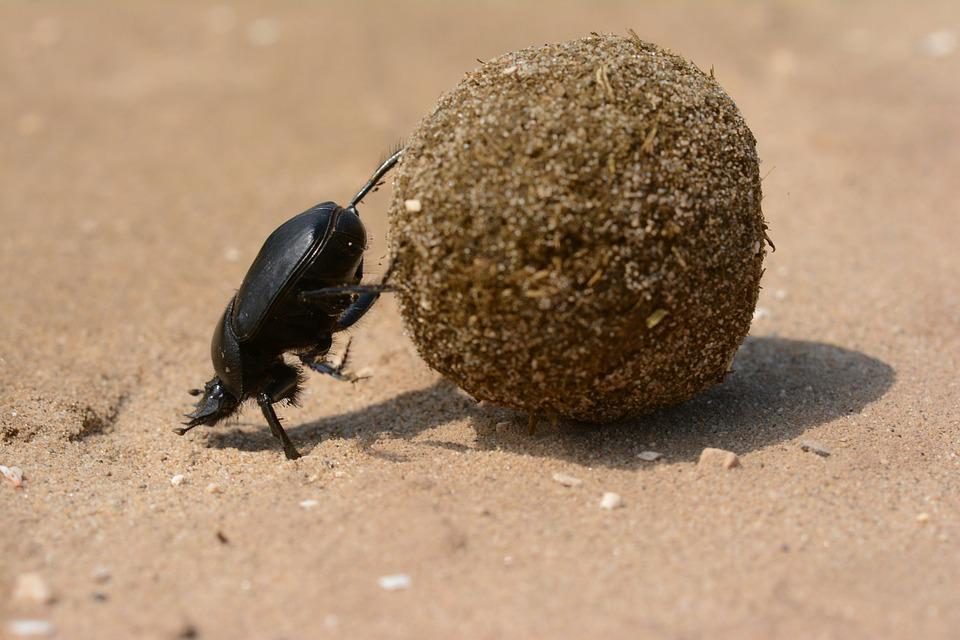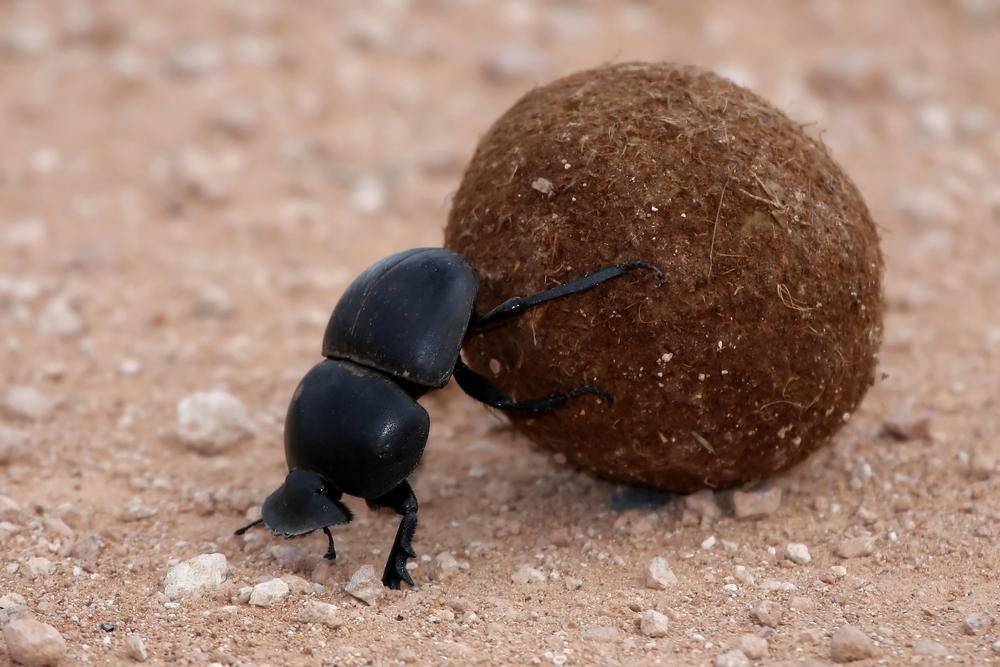The first image is the image on the left, the second image is the image on the right. For the images shown, is this caption "A beetle is turned toward the left side of the photo in both images." true? Answer yes or no. Yes. The first image is the image on the left, the second image is the image on the right. Considering the images on both sides, is "Both images show beetles on dung balls with their bodies in the same general pose and location." valid? Answer yes or no. Yes. 